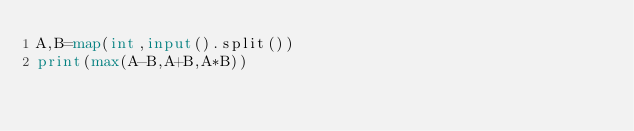<code> <loc_0><loc_0><loc_500><loc_500><_Python_>A,B=map(int,input().split())
print(max(A-B,A+B,A*B))</code> 